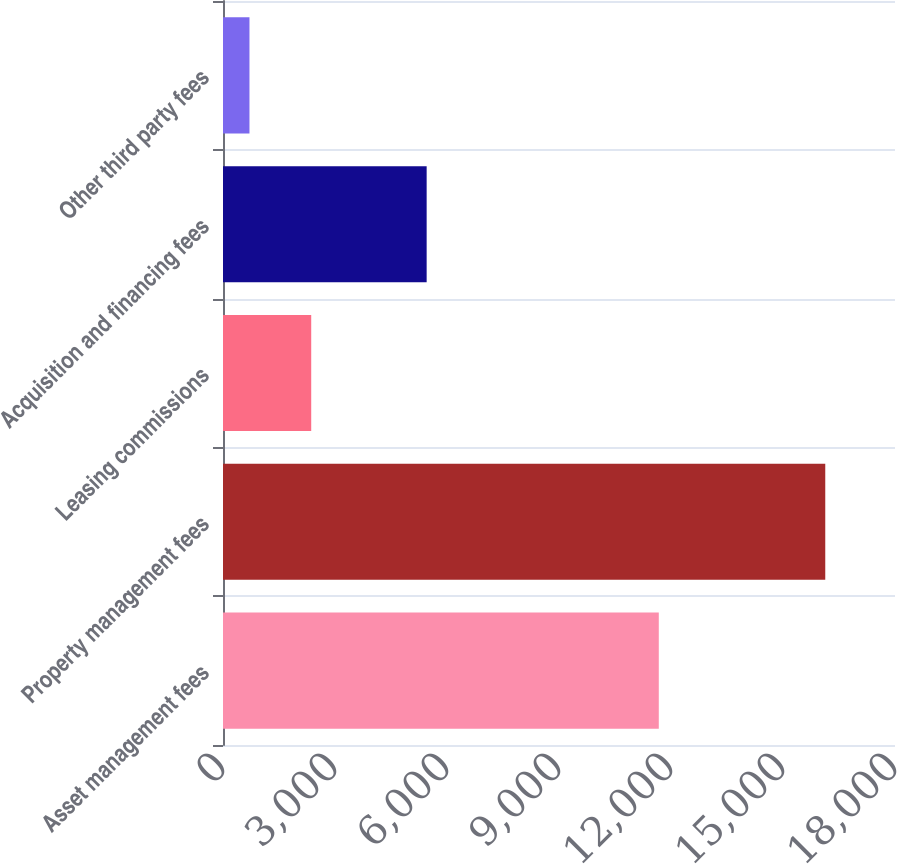Convert chart to OTSL. <chart><loc_0><loc_0><loc_500><loc_500><bar_chart><fcel>Asset management fees<fcel>Property management fees<fcel>Leasing commissions<fcel>Acquisition and financing fees<fcel>Other third party fees<nl><fcel>11673<fcel>16132<fcel>2363<fcel>5455<fcel>709<nl></chart> 